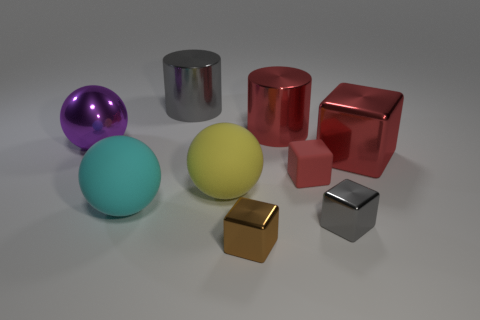What number of other objects are the same shape as the tiny brown metal object?
Provide a succinct answer. 3. What shape is the tiny thing that is behind the brown metal thing and on the left side of the tiny gray block?
Your answer should be compact. Cube. Is there another purple ball that has the same material as the big purple ball?
Make the answer very short. No. The other cube that is the same color as the matte block is what size?
Ensure brevity in your answer.  Large. The large metallic object in front of the purple thing is what color?
Your answer should be compact. Red. Is the shape of the brown thing the same as the red metal thing right of the gray cube?
Offer a terse response. Yes. Are there any rubber cylinders that have the same color as the large shiny ball?
Provide a short and direct response. No. What is the size of the cyan object that is the same material as the large yellow sphere?
Provide a short and direct response. Large. Do the tiny matte object and the large metallic block have the same color?
Provide a succinct answer. Yes. There is a tiny object that is behind the tiny gray cube; does it have the same shape as the brown metallic thing?
Provide a short and direct response. Yes. 